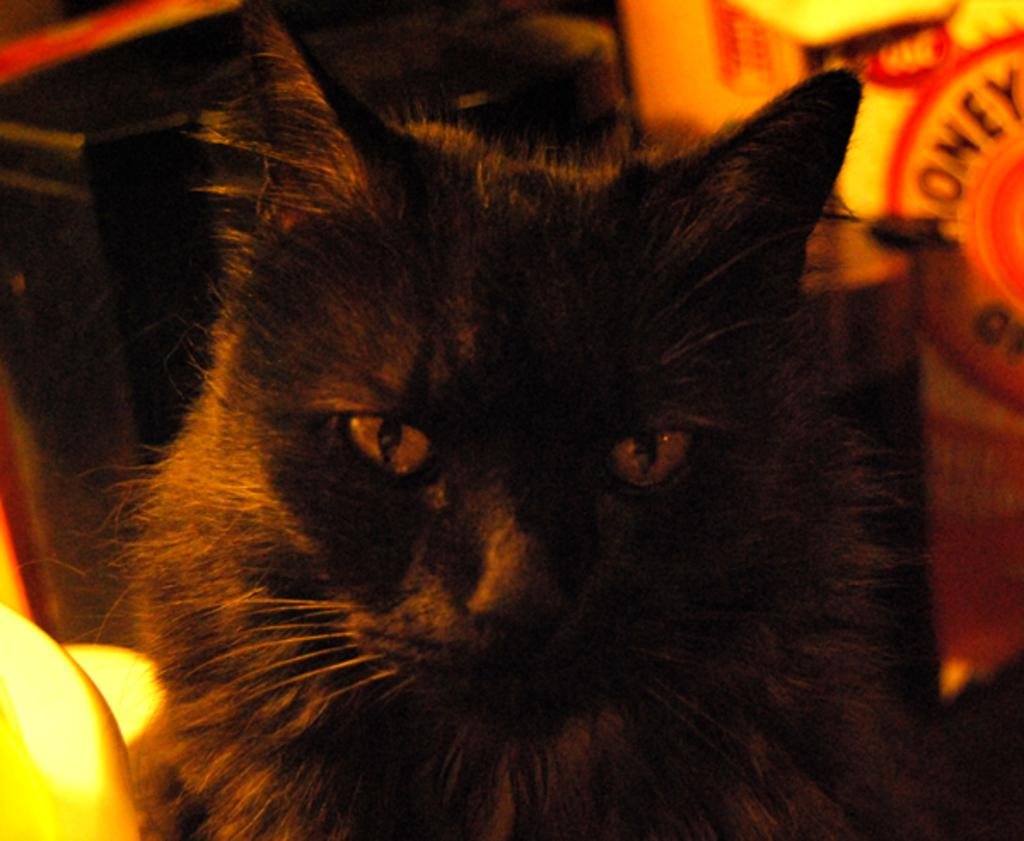What is the main subject of the image? There is a cat in the center of the image. What can be seen in the background of the image? There are objects in the background of the image. Is there any text present in the image? Yes, there is text visible in the image. Can you see any popcorn floating in the river in the image? There is no river or popcorn present in the image. What type of skin condition does the cat have in the image? There is no indication of any skin condition on the cat in the image. 